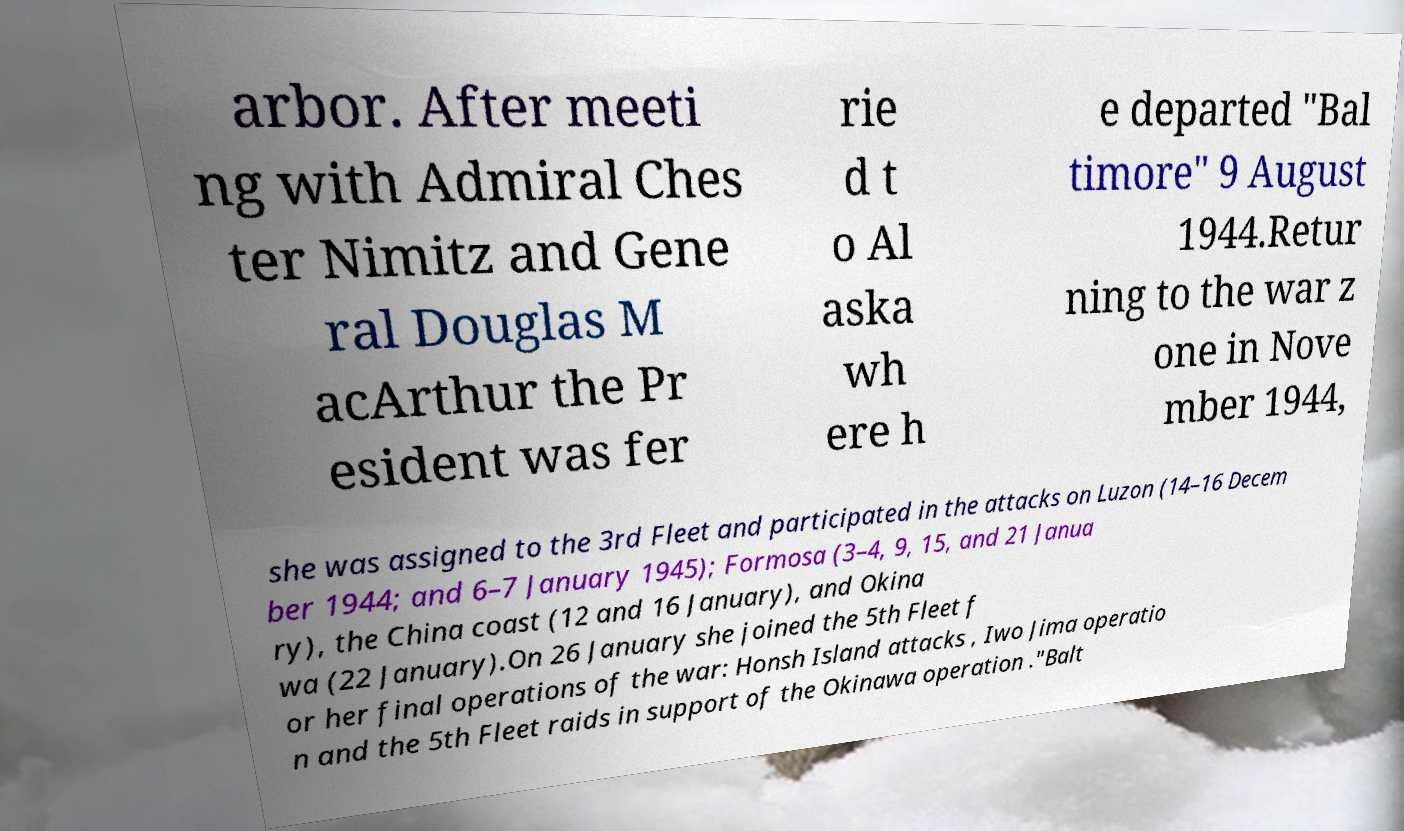Could you extract and type out the text from this image? arbor. After meeti ng with Admiral Ches ter Nimitz and Gene ral Douglas M acArthur the Pr esident was fer rie d t o Al aska wh ere h e departed "Bal timore" 9 August 1944.Retur ning to the war z one in Nove mber 1944, she was assigned to the 3rd Fleet and participated in the attacks on Luzon (14–16 Decem ber 1944; and 6–7 January 1945); Formosa (3–4, 9, 15, and 21 Janua ry), the China coast (12 and 16 January), and Okina wa (22 January).On 26 January she joined the 5th Fleet f or her final operations of the war: Honsh Island attacks , Iwo Jima operatio n and the 5th Fleet raids in support of the Okinawa operation ."Balt 